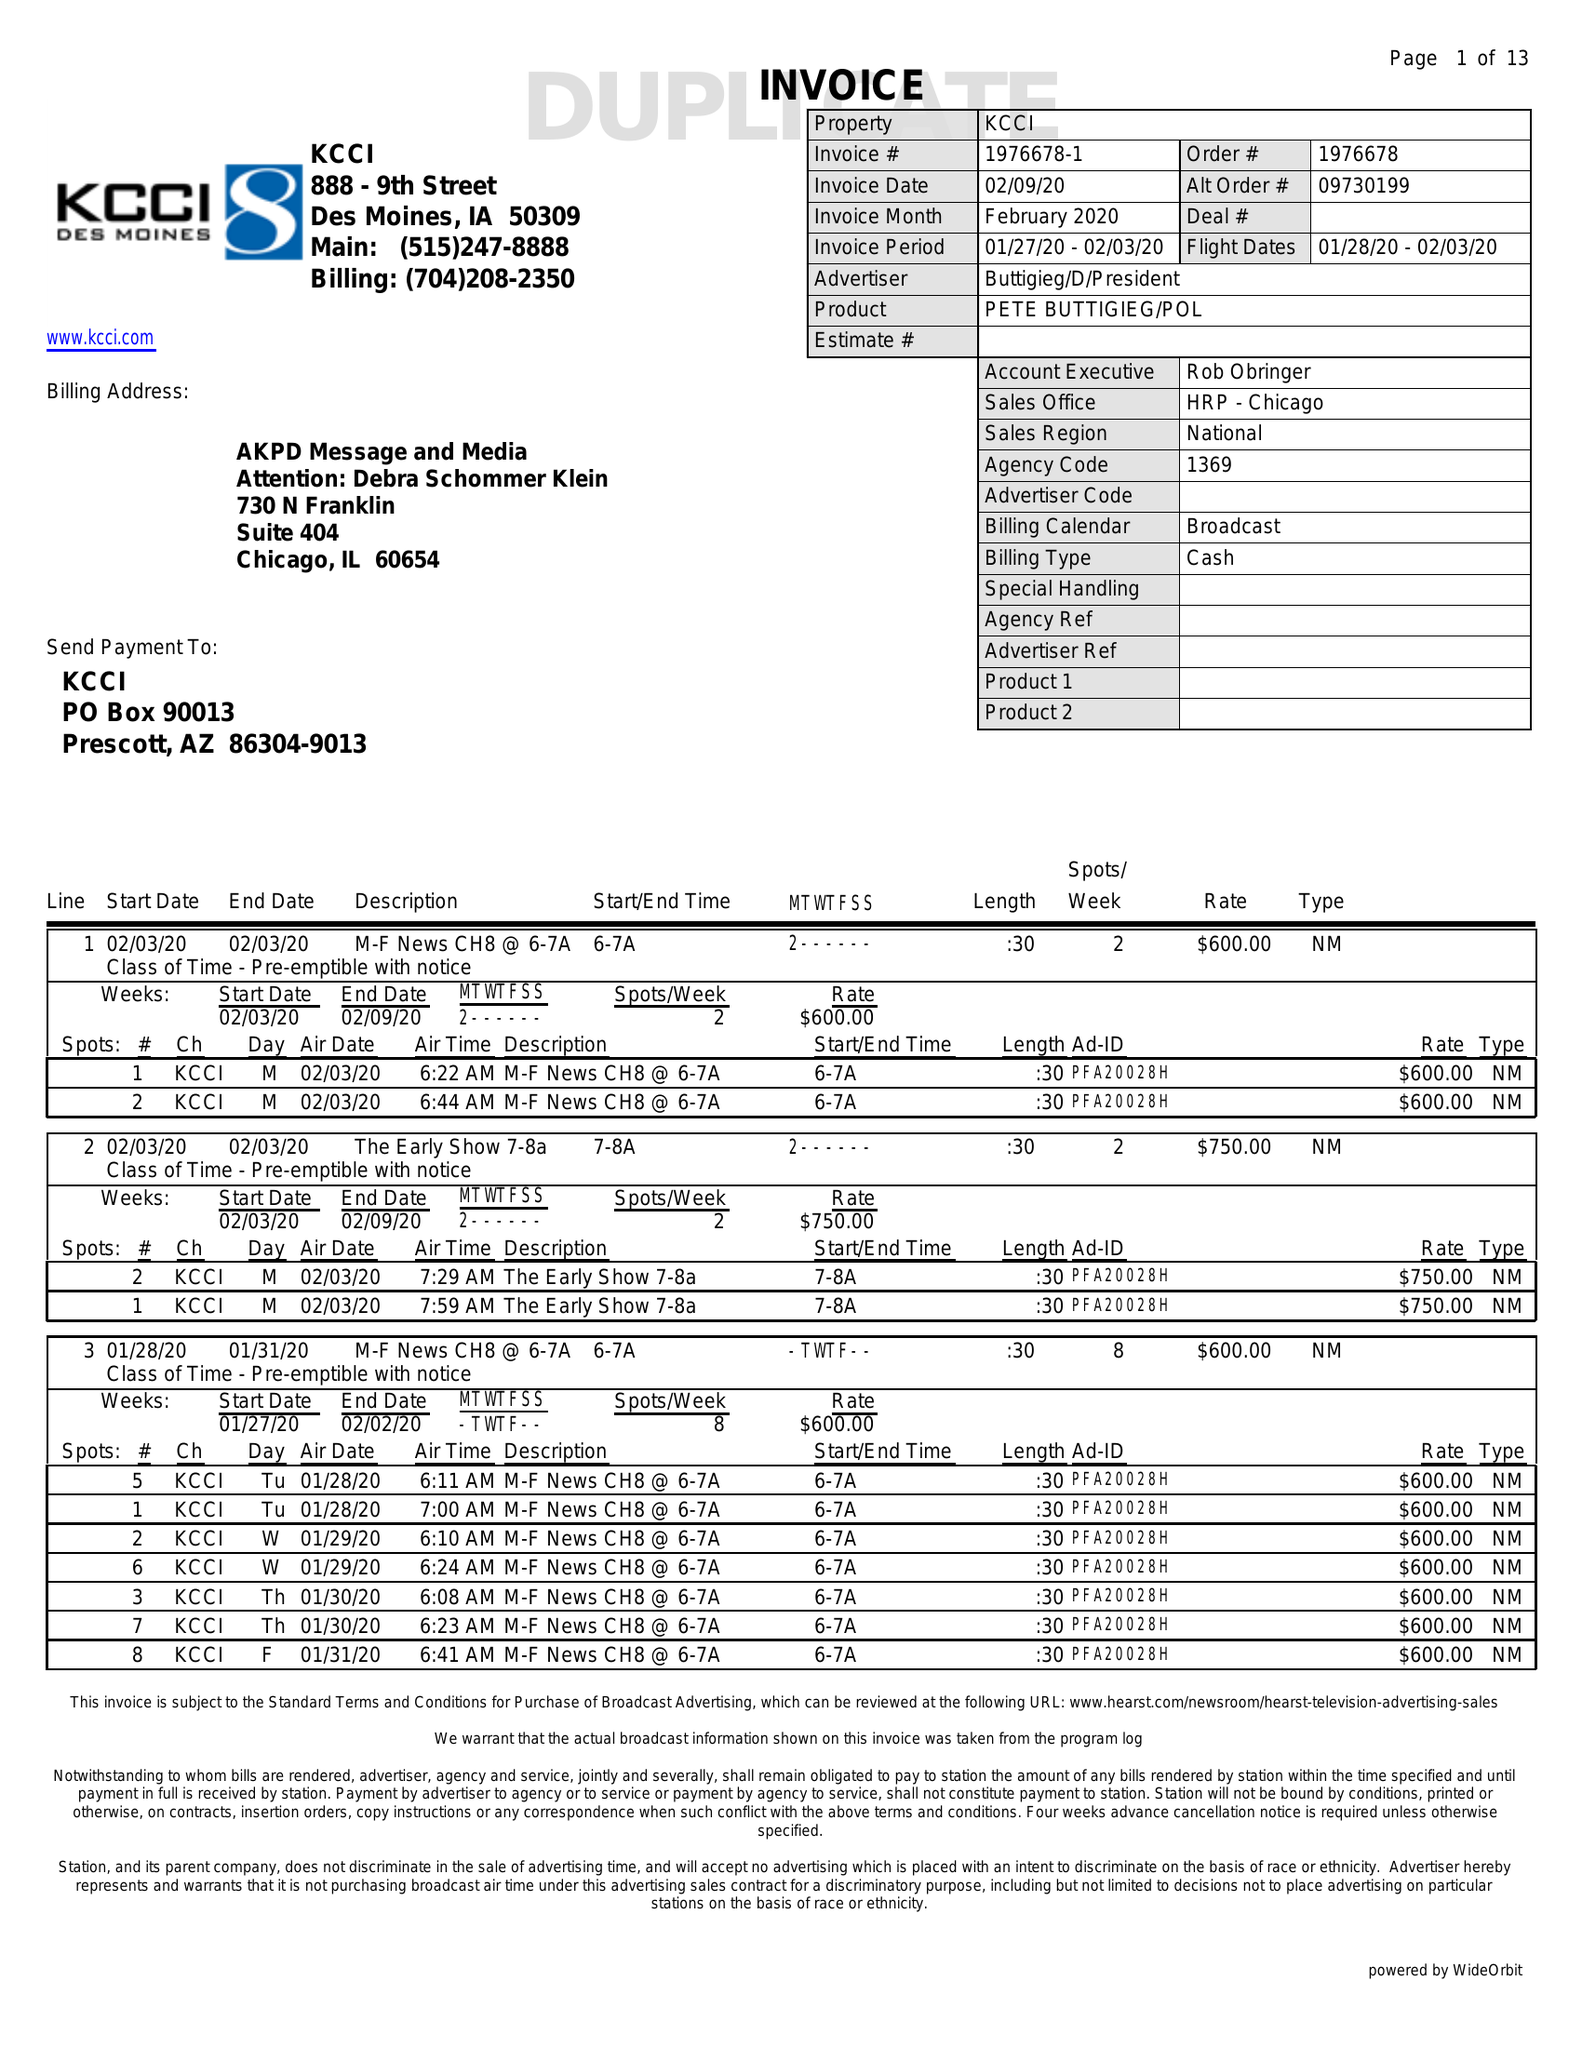What is the value for the flight_from?
Answer the question using a single word or phrase. 01/27/20 